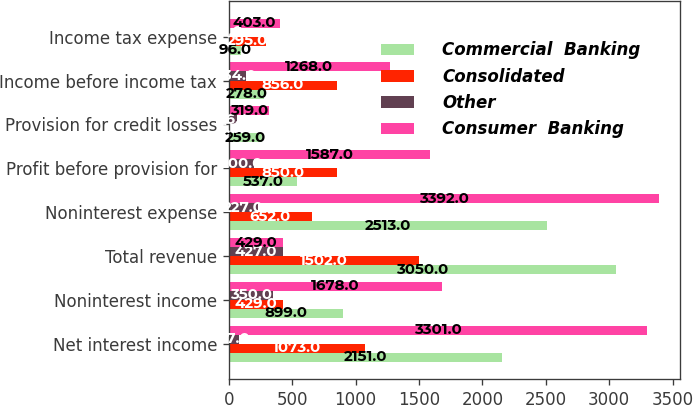Convert chart. <chart><loc_0><loc_0><loc_500><loc_500><stacked_bar_chart><ecel><fcel>Net interest income<fcel>Noninterest income<fcel>Total revenue<fcel>Noninterest expense<fcel>Profit before provision for<fcel>Provision for credit losses<fcel>Income before income tax<fcel>Income tax expense<nl><fcel>Commercial  Banking<fcel>2151<fcel>899<fcel>3050<fcel>2513<fcel>537<fcel>259<fcel>278<fcel>96<nl><fcel>Consolidated<fcel>1073<fcel>429<fcel>1502<fcel>652<fcel>850<fcel>6<fcel>856<fcel>295<nl><fcel>Other<fcel>77<fcel>350<fcel>427<fcel>227<fcel>200<fcel>66<fcel>134<fcel>12<nl><fcel>Consumer  Banking<fcel>3301<fcel>1678<fcel>429<fcel>3392<fcel>1587<fcel>319<fcel>1268<fcel>403<nl></chart> 